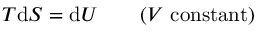Convert formula to latex. <formula><loc_0><loc_0><loc_500><loc_500>T d S = d U \, ( V \, { c o n s t a n t ) }</formula> 